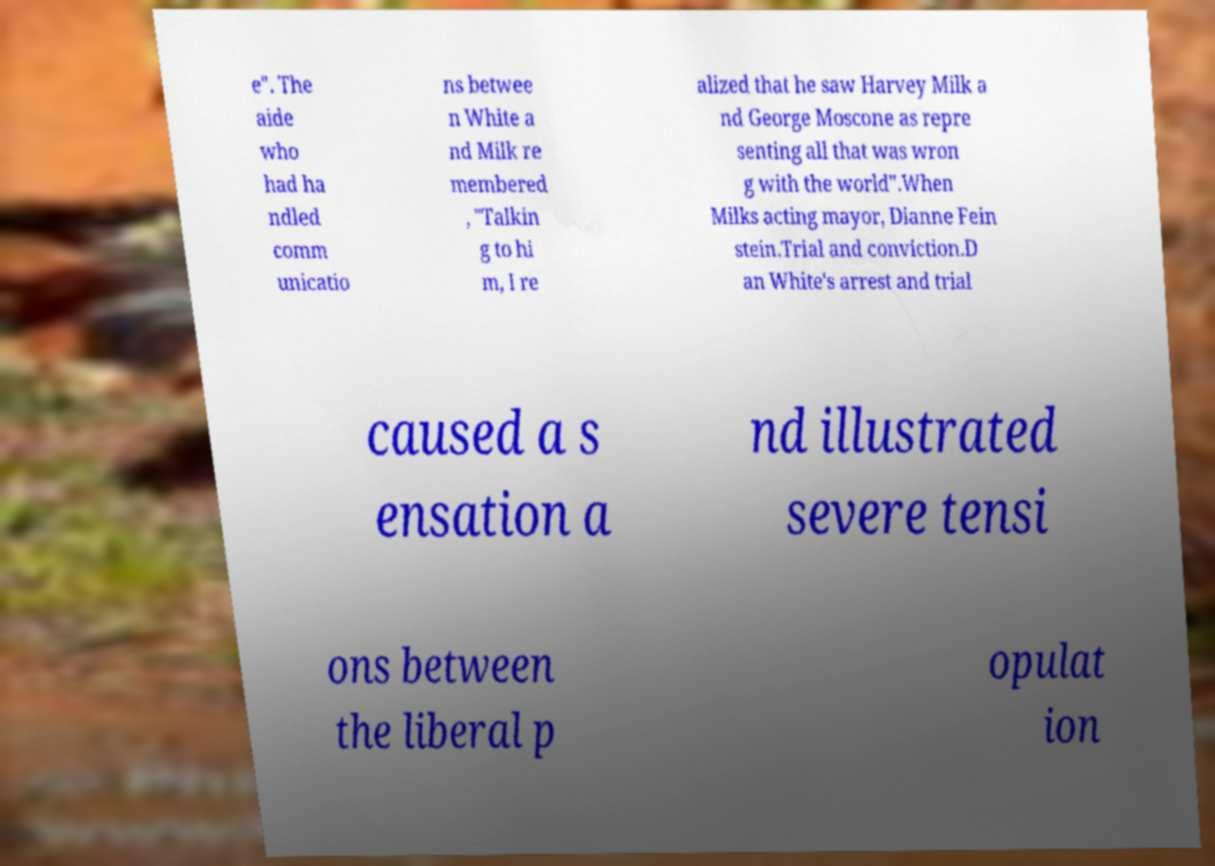There's text embedded in this image that I need extracted. Can you transcribe it verbatim? e". The aide who had ha ndled comm unicatio ns betwee n White a nd Milk re membered , "Talkin g to hi m, I re alized that he saw Harvey Milk a nd George Moscone as repre senting all that was wron g with the world".When Milks acting mayor, Dianne Fein stein.Trial and conviction.D an White's arrest and trial caused a s ensation a nd illustrated severe tensi ons between the liberal p opulat ion 